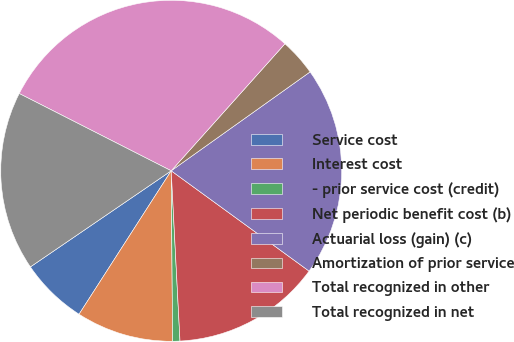Convert chart to OTSL. <chart><loc_0><loc_0><loc_500><loc_500><pie_chart><fcel>Service cost<fcel>Interest cost<fcel>- prior service cost (credit)<fcel>Net periodic benefit cost (b)<fcel>Actuarial loss (gain) (c)<fcel>Amortization of prior service<fcel>Total recognized in other<fcel>Total recognized in net<nl><fcel>6.38%<fcel>9.22%<fcel>0.69%<fcel>14.17%<fcel>19.86%<fcel>3.53%<fcel>29.14%<fcel>17.02%<nl></chart> 